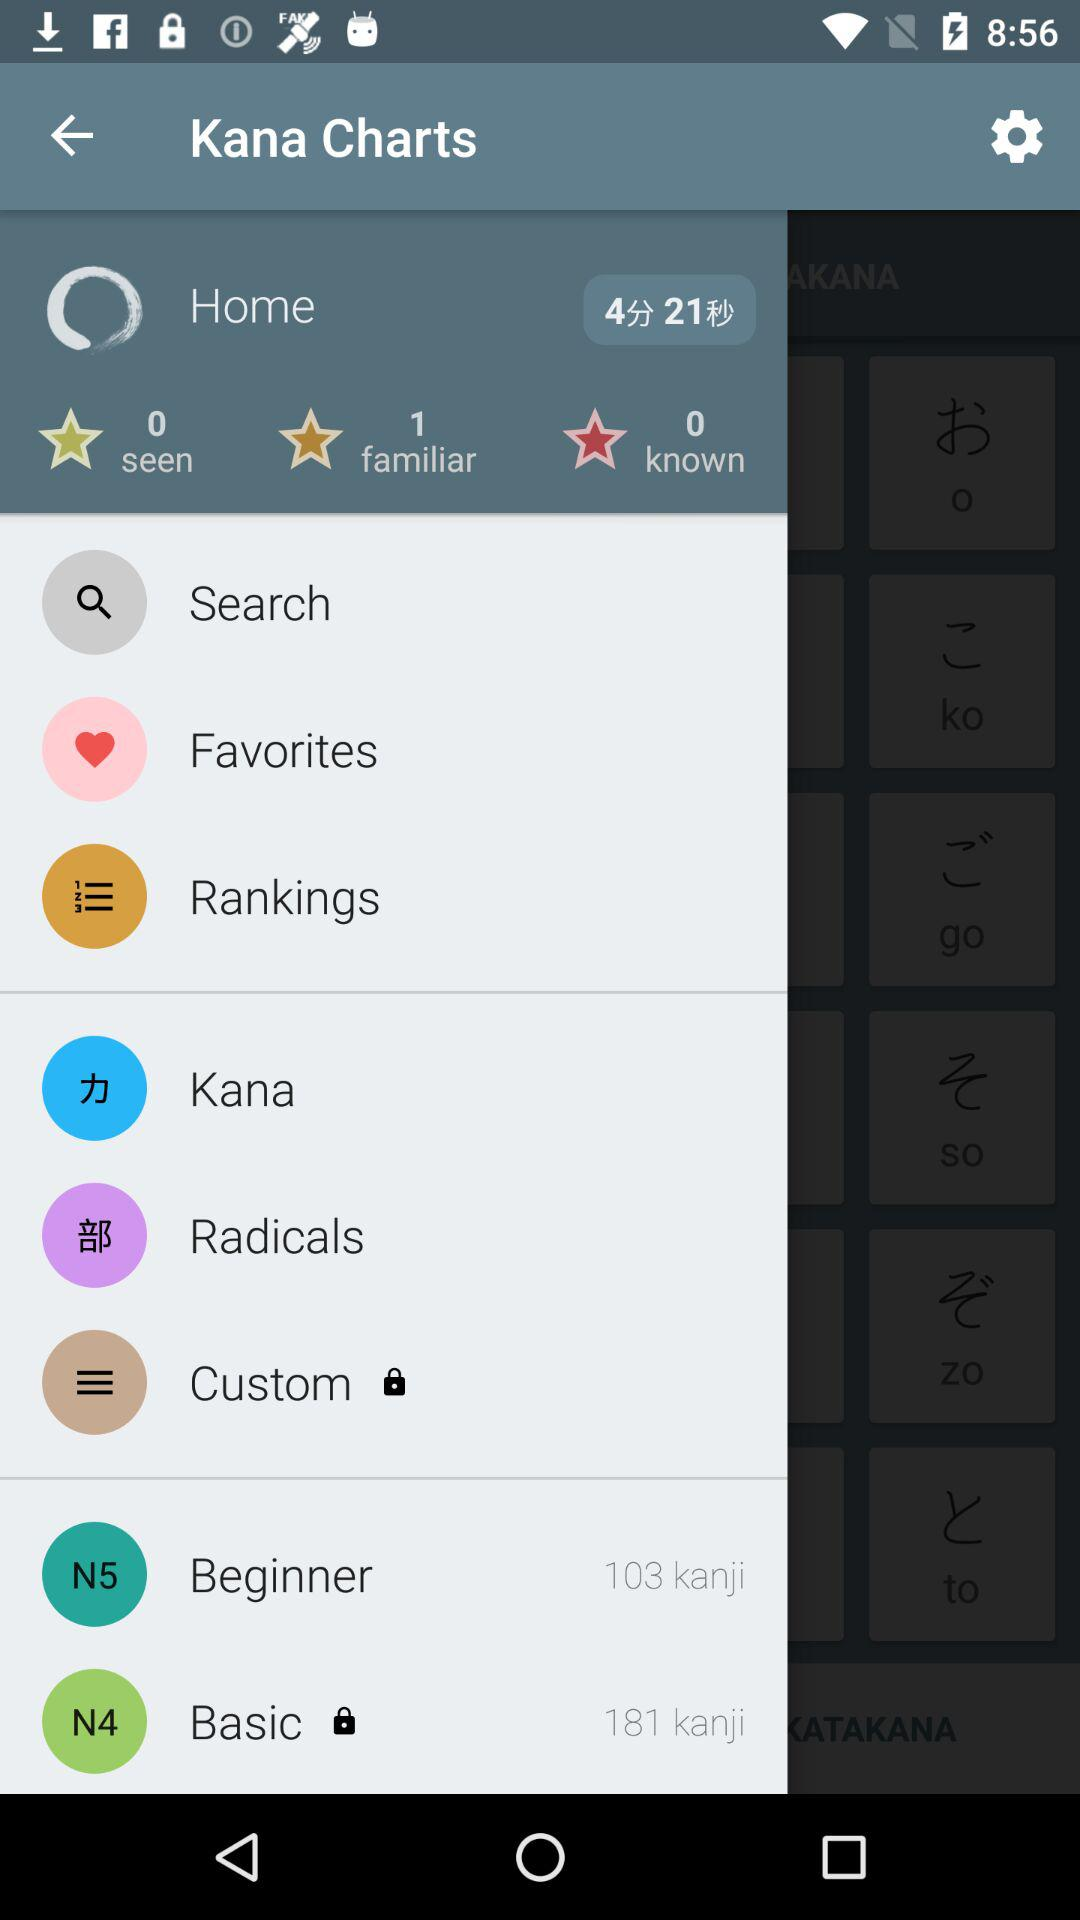What is the application name? The application name is "Kana Charts". 